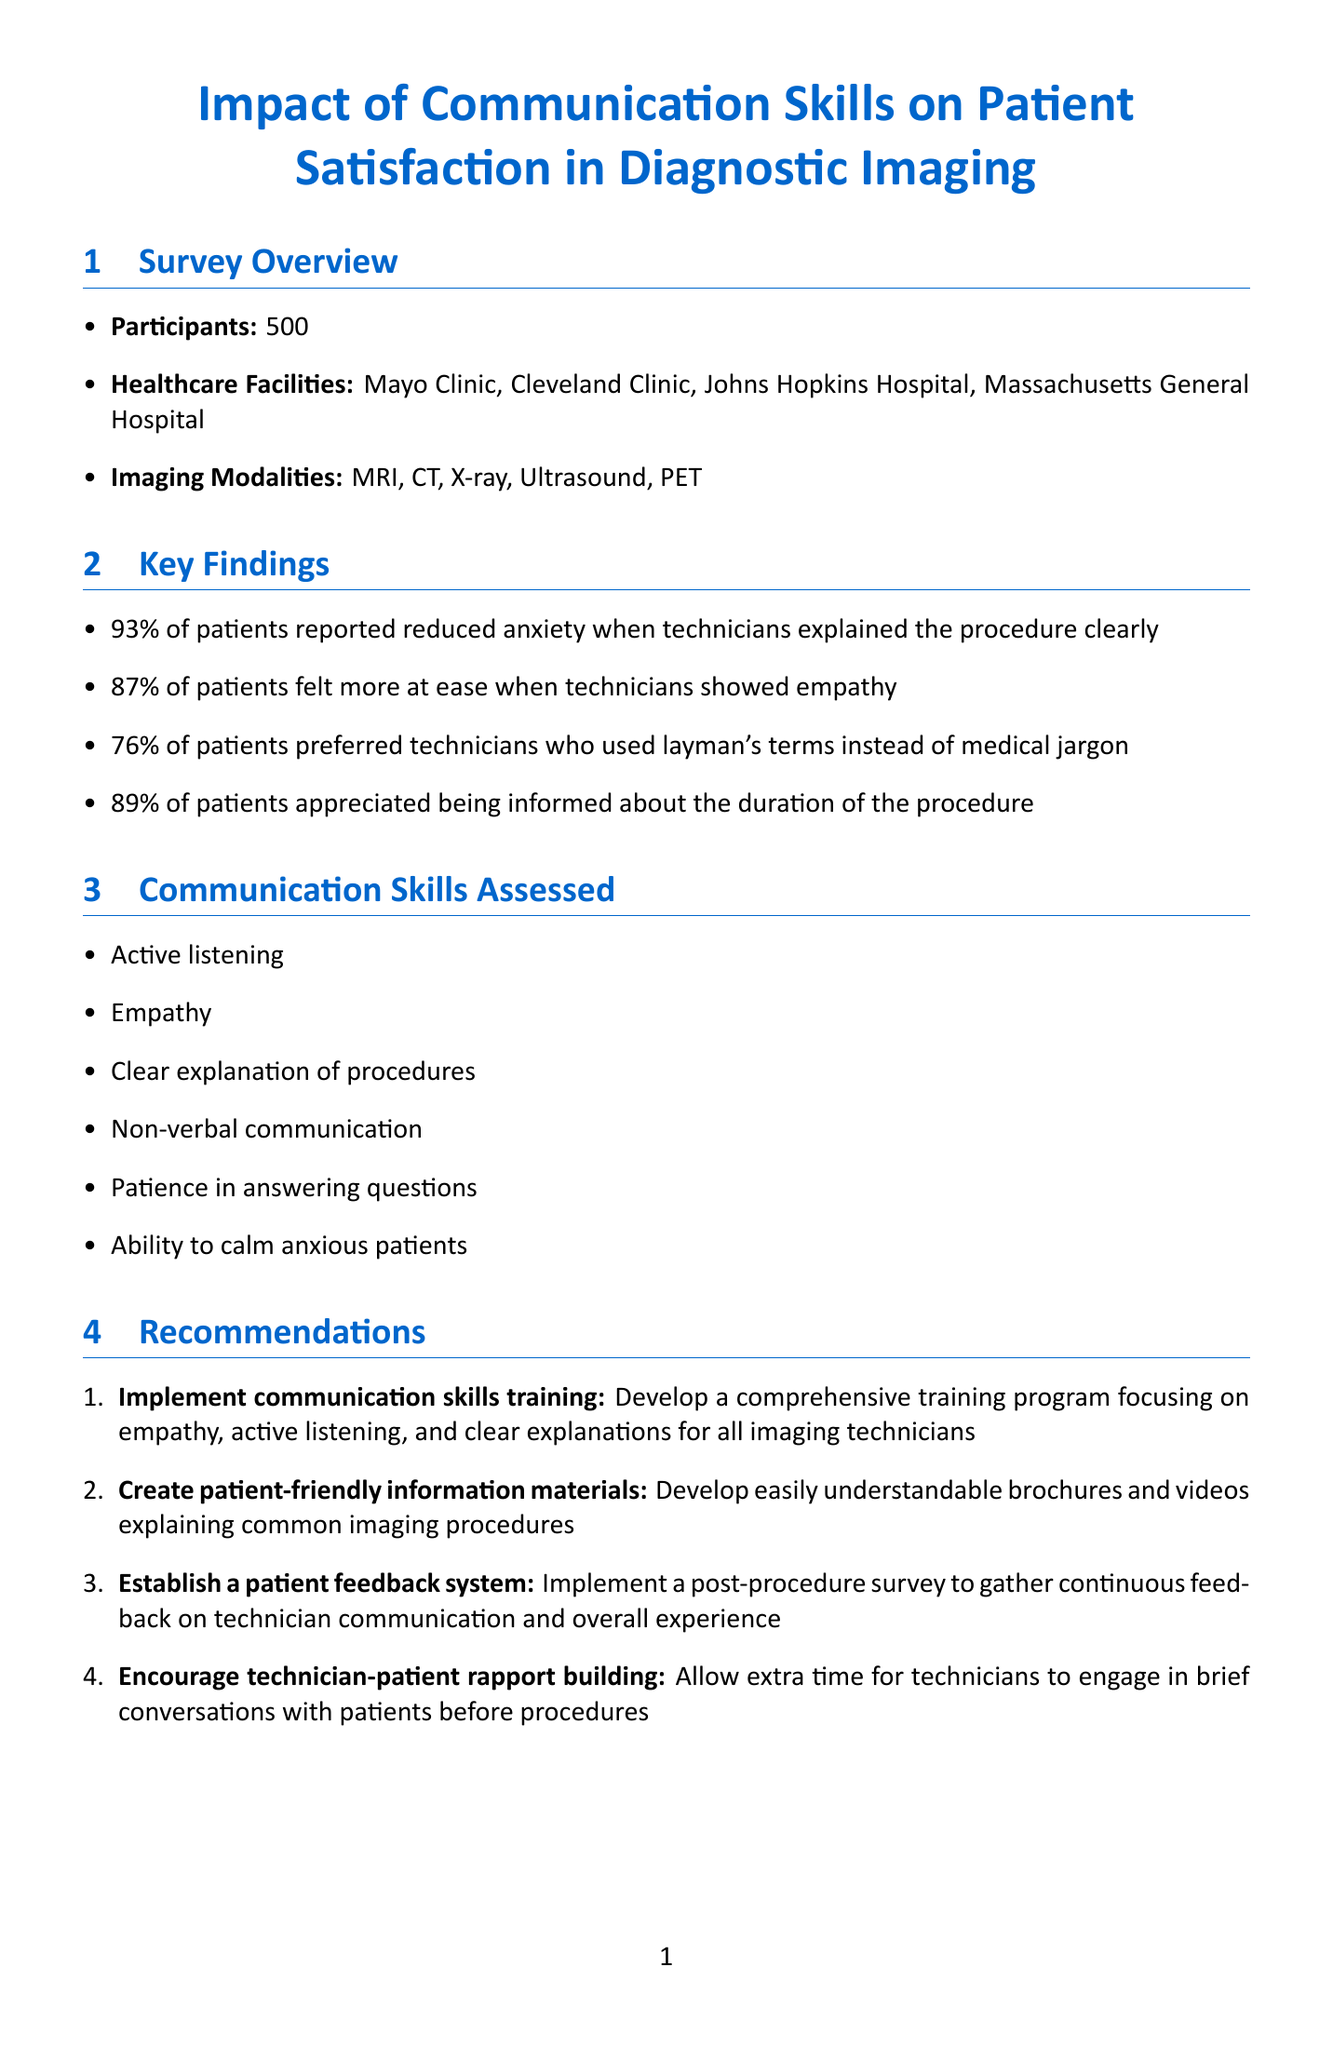What percentage of patients reported reduced anxiety with clear explanations? The document states that 93% of patients reported reduced anxiety when technicians explained the procedure clearly.
Answer: 93% Which healthcare facility conducted a communication skills workshop? The case study mentions Cedars-Sinai Medical Center implemented a 2-day communication skills workshop for all imaging technicians.
Answer: Cedars-Sinai Medical Center What is one of the communication skills assessed in the survey? The communication skills assessed include active listening, empathy, and clear explanation of procedures, among others. Active listening is one of them.
Answer: Active listening What was the expected outcome of creating patient-friendly information materials? The expected outcome mentioned is that better informed patients can lead to reduced fear of the unknown.
Answer: Reduced fear of the unknown What percentage of patients preferred layman's terms over medical jargon? The document indicates that 76% of patients preferred technicians who used layman's terms instead of medical jargon.
Answer: 76% 